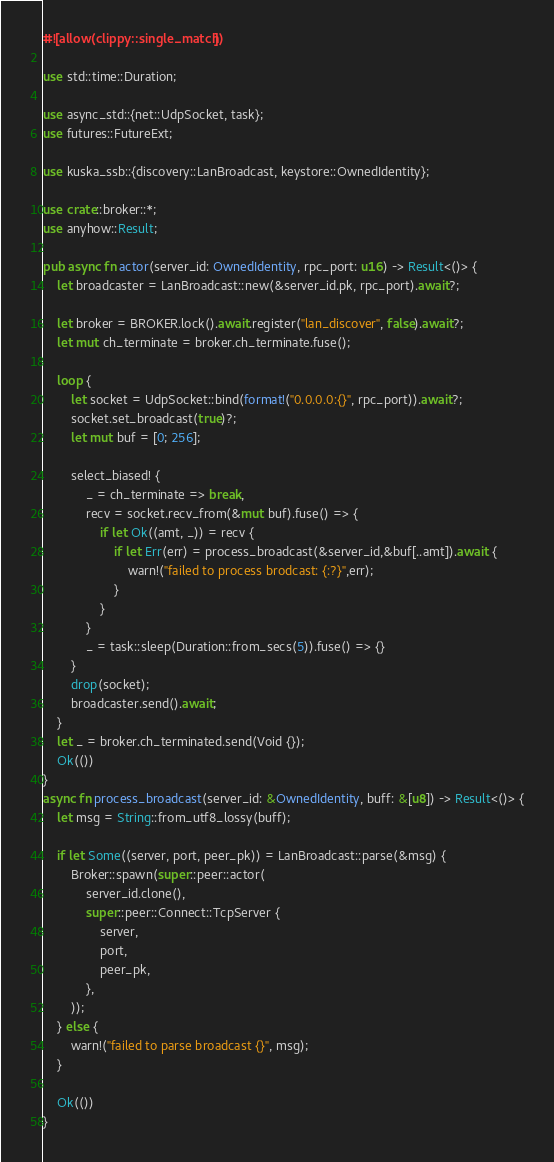Convert code to text. <code><loc_0><loc_0><loc_500><loc_500><_Rust_>#![allow(clippy::single_match)]

use std::time::Duration;

use async_std::{net::UdpSocket, task};
use futures::FutureExt;

use kuska_ssb::{discovery::LanBroadcast, keystore::OwnedIdentity};

use crate::broker::*;
use anyhow::Result;

pub async fn actor(server_id: OwnedIdentity, rpc_port: u16) -> Result<()> {
    let broadcaster = LanBroadcast::new(&server_id.pk, rpc_port).await?;

    let broker = BROKER.lock().await.register("lan_discover", false).await?;
    let mut ch_terminate = broker.ch_terminate.fuse();

    loop {
        let socket = UdpSocket::bind(format!("0.0.0.0:{}", rpc_port)).await?;
        socket.set_broadcast(true)?;
        let mut buf = [0; 256];

        select_biased! {
            _ = ch_terminate => break,
            recv = socket.recv_from(&mut buf).fuse() => {
                if let Ok((amt, _)) = recv {
                    if let Err(err) = process_broadcast(&server_id,&buf[..amt]).await {
                        warn!("failed to process brodcast: {:?}",err);
                    }
                }
            }
            _ = task::sleep(Duration::from_secs(5)).fuse() => {}
        }
        drop(socket);
        broadcaster.send().await;
    }
    let _ = broker.ch_terminated.send(Void {});
    Ok(())
}
async fn process_broadcast(server_id: &OwnedIdentity, buff: &[u8]) -> Result<()> {
    let msg = String::from_utf8_lossy(buff);

    if let Some((server, port, peer_pk)) = LanBroadcast::parse(&msg) {
        Broker::spawn(super::peer::actor(
            server_id.clone(),
            super::peer::Connect::TcpServer {
                server,
                port,
                peer_pk,
            },
        ));
    } else {
        warn!("failed to parse broadcast {}", msg);
    }

    Ok(())
}
</code> 